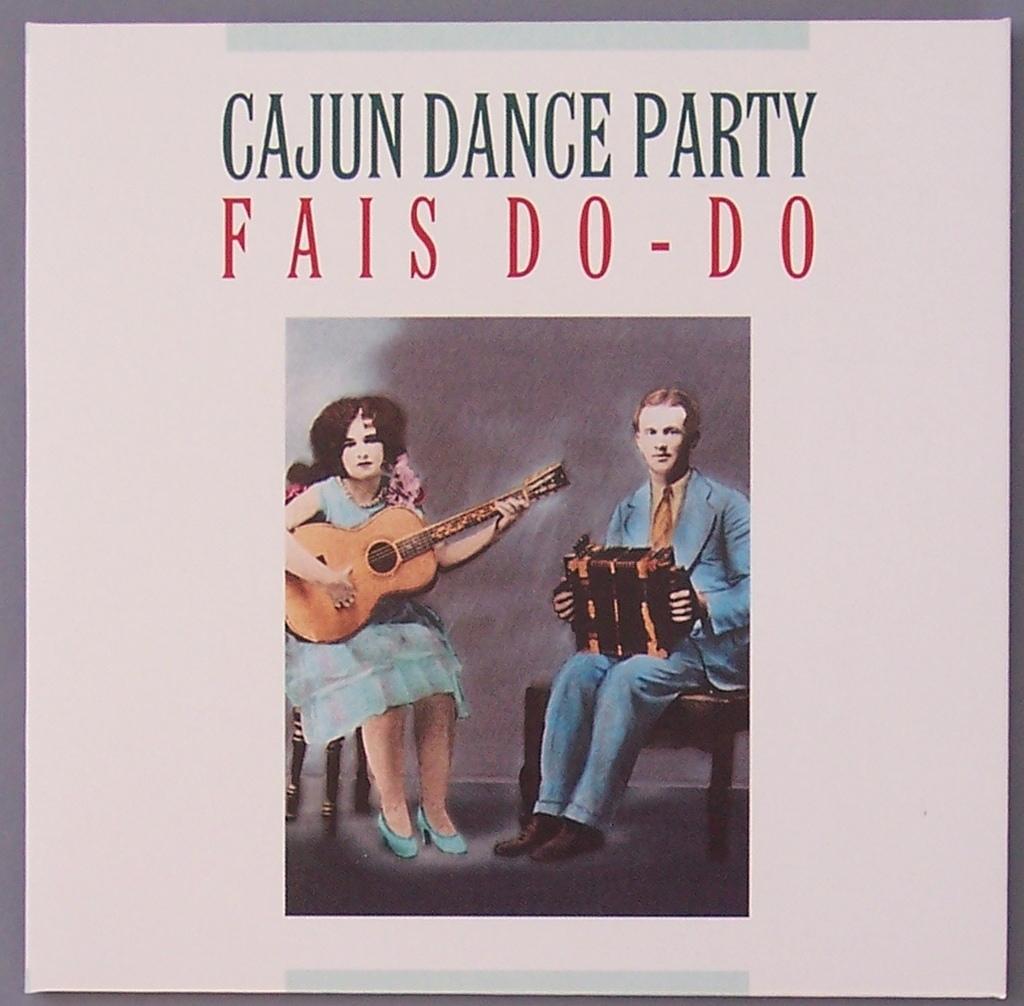In one or two sentences, can you explain what this image depicts? In this image we can see there is a poster. On the poster there are two persons sitting on chairs and playing musical instruments and there is some text on it. 